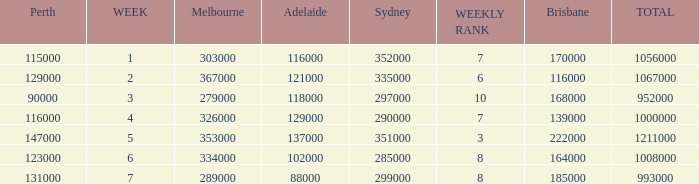How many viewers were there in Sydney for the episode when there were 334000 in Melbourne? 285000.0. 